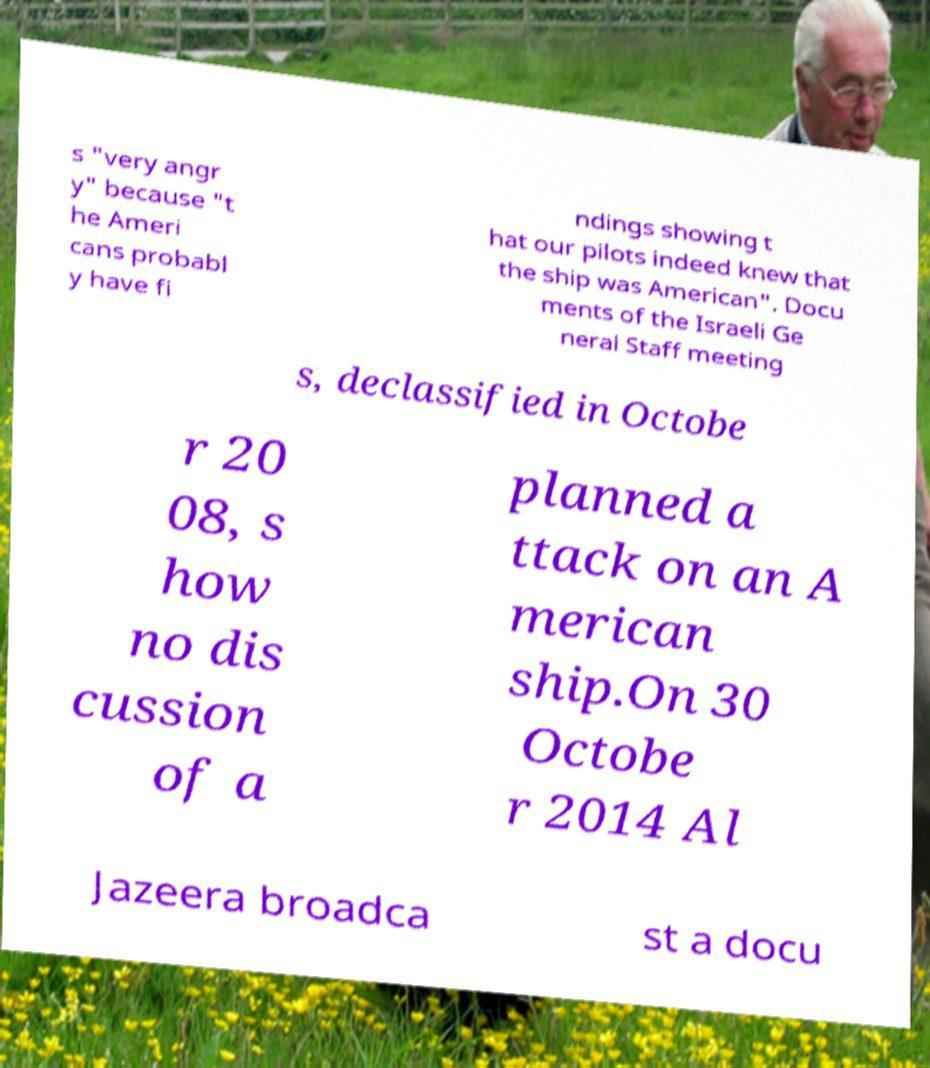Can you read and provide the text displayed in the image?This photo seems to have some interesting text. Can you extract and type it out for me? s "very angr y" because "t he Ameri cans probabl y have fi ndings showing t hat our pilots indeed knew that the ship was American". Docu ments of the Israeli Ge neral Staff meeting s, declassified in Octobe r 20 08, s how no dis cussion of a planned a ttack on an A merican ship.On 30 Octobe r 2014 Al Jazeera broadca st a docu 